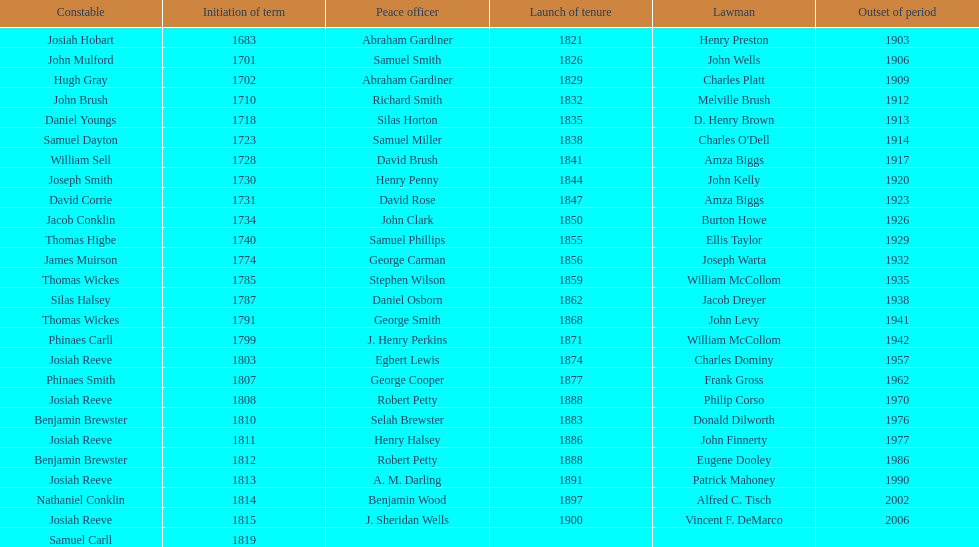Which sheriff came before thomas wickes? James Muirson. 